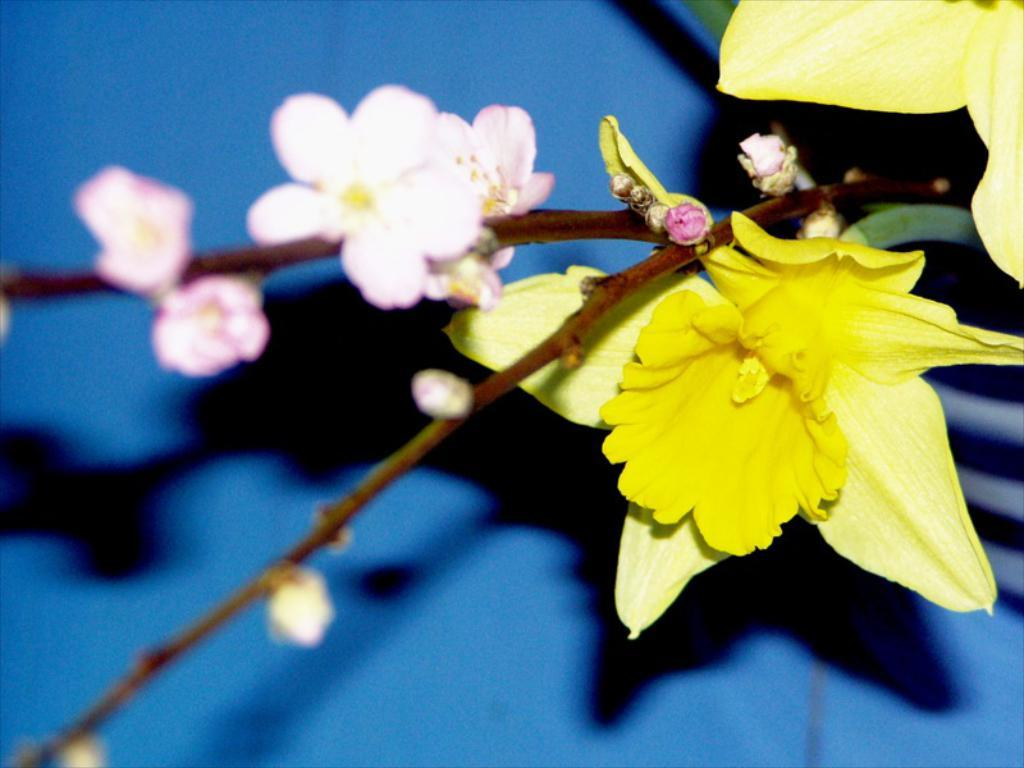What type of plants can be seen in the image? There are flowers in the image. What color is the background of the image? The background color is blue. What type of liquid is flowing from the stone in the image? There is no liquid or stone present in the image; it only features flowers and a blue background. 